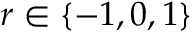<formula> <loc_0><loc_0><loc_500><loc_500>r \in \left \{ { - 1 , 0 , 1 } \right \}</formula> 